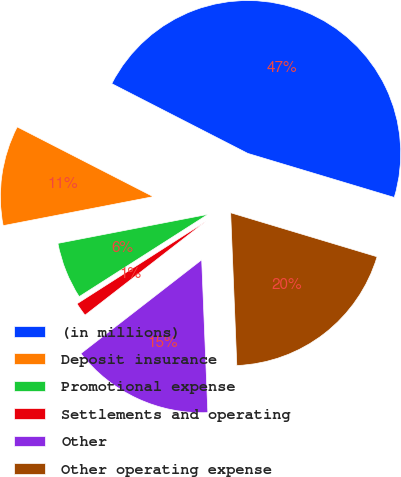Convert chart to OTSL. <chart><loc_0><loc_0><loc_500><loc_500><pie_chart><fcel>(in millions)<fcel>Deposit insurance<fcel>Promotional expense<fcel>Settlements and operating<fcel>Other<fcel>Other operating expense<nl><fcel>47.1%<fcel>10.58%<fcel>6.01%<fcel>1.45%<fcel>15.14%<fcel>19.71%<nl></chart> 